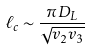Convert formula to latex. <formula><loc_0><loc_0><loc_500><loc_500>\ell _ { c } \sim \frac { \pi D _ { L } } { \sqrt { v _ { 2 } v _ { 3 } } }</formula> 